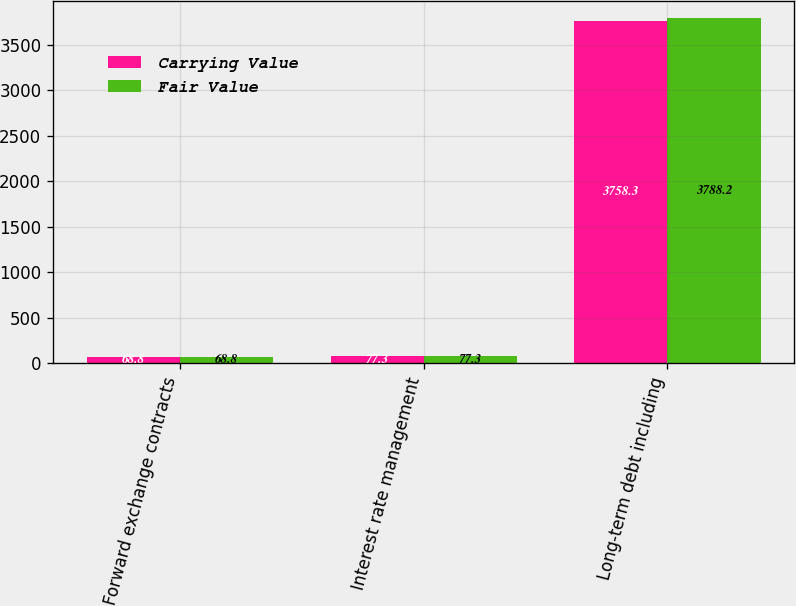<chart> <loc_0><loc_0><loc_500><loc_500><stacked_bar_chart><ecel><fcel>Forward exchange contracts<fcel>Interest rate management<fcel>Long-term debt including<nl><fcel>Carrying Value<fcel>68.8<fcel>77.3<fcel>3758.3<nl><fcel>Fair Value<fcel>68.8<fcel>77.3<fcel>3788.2<nl></chart> 